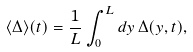<formula> <loc_0><loc_0><loc_500><loc_500>\langle \Delta \rangle ( t ) = \frac { 1 } { L } \int ^ { L } _ { 0 } d y \, \Delta ( y , t ) ,</formula> 